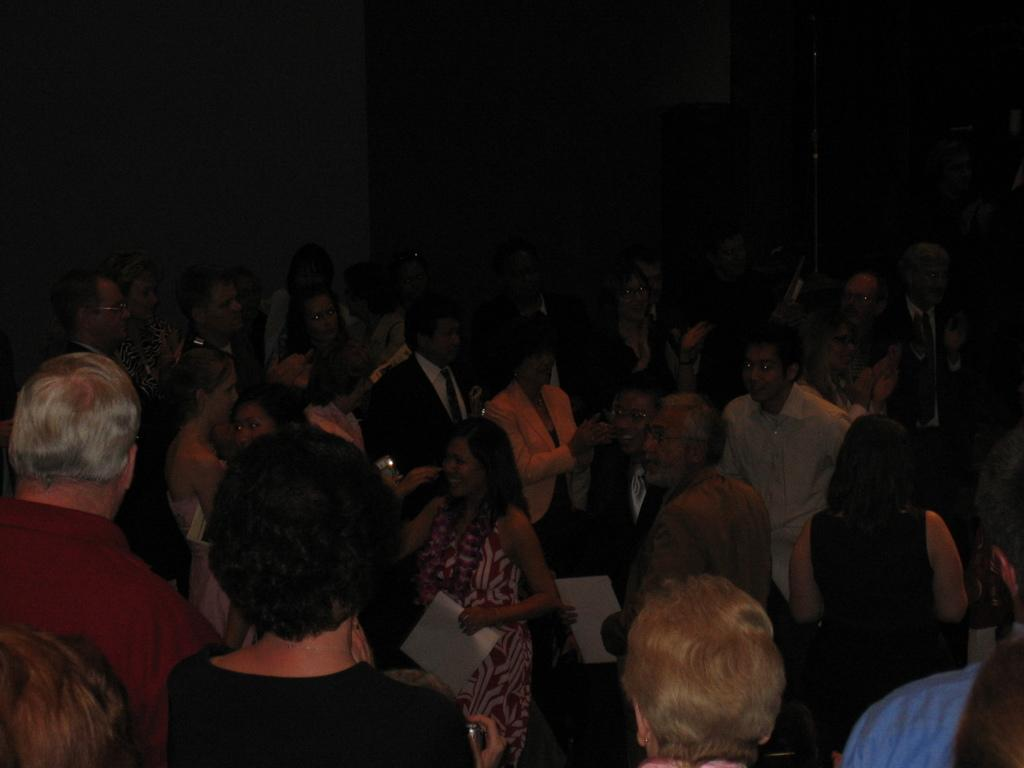How many people are present in the image? There are many people in the image. What are some of the people holding in the image? Some of the people are holding papers. What can be seen in the background of the image? There is a wall in the background of the image. Where is the throne located in the image? There is no throne present in the image. Are there any fairies visible in the image? There are no fairies present in the image. 